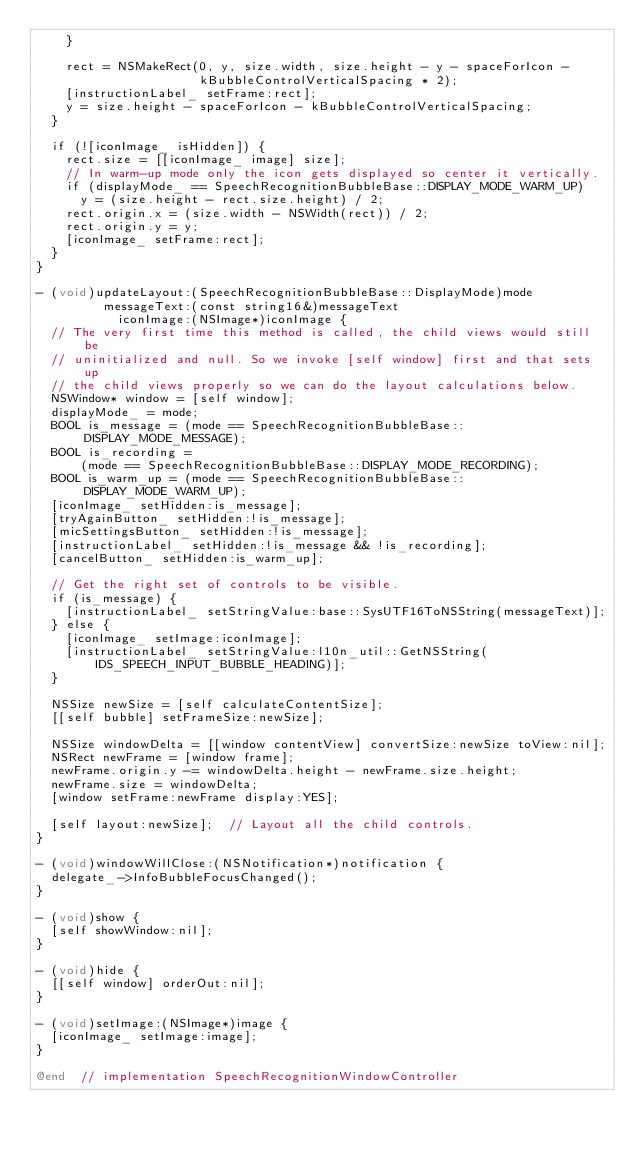<code> <loc_0><loc_0><loc_500><loc_500><_ObjectiveC_>    }

    rect = NSMakeRect(0, y, size.width, size.height - y - spaceForIcon -
                      kBubbleControlVerticalSpacing * 2);
    [instructionLabel_ setFrame:rect];
    y = size.height - spaceForIcon - kBubbleControlVerticalSpacing;
  }

  if (![iconImage_ isHidden]) {
    rect.size = [[iconImage_ image] size];
    // In warm-up mode only the icon gets displayed so center it vertically.
    if (displayMode_ == SpeechRecognitionBubbleBase::DISPLAY_MODE_WARM_UP)
      y = (size.height - rect.size.height) / 2;
    rect.origin.x = (size.width - NSWidth(rect)) / 2;
    rect.origin.y = y;
    [iconImage_ setFrame:rect];
  }
}

- (void)updateLayout:(SpeechRecognitionBubbleBase::DisplayMode)mode
         messageText:(const string16&)messageText
           iconImage:(NSImage*)iconImage {
  // The very first time this method is called, the child views would still be
  // uninitialized and null. So we invoke [self window] first and that sets up
  // the child views properly so we can do the layout calculations below.
  NSWindow* window = [self window];
  displayMode_ = mode;
  BOOL is_message = (mode == SpeechRecognitionBubbleBase::DISPLAY_MODE_MESSAGE);
  BOOL is_recording =
      (mode == SpeechRecognitionBubbleBase::DISPLAY_MODE_RECORDING);
  BOOL is_warm_up = (mode == SpeechRecognitionBubbleBase::DISPLAY_MODE_WARM_UP);
  [iconImage_ setHidden:is_message];
  [tryAgainButton_ setHidden:!is_message];
  [micSettingsButton_ setHidden:!is_message];
  [instructionLabel_ setHidden:!is_message && !is_recording];
  [cancelButton_ setHidden:is_warm_up];

  // Get the right set of controls to be visible.
  if (is_message) {
    [instructionLabel_ setStringValue:base::SysUTF16ToNSString(messageText)];
  } else {
    [iconImage_ setImage:iconImage];
    [instructionLabel_ setStringValue:l10n_util::GetNSString(
        IDS_SPEECH_INPUT_BUBBLE_HEADING)];
  }

  NSSize newSize = [self calculateContentSize];
  [[self bubble] setFrameSize:newSize];

  NSSize windowDelta = [[window contentView] convertSize:newSize toView:nil];
  NSRect newFrame = [window frame];
  newFrame.origin.y -= windowDelta.height - newFrame.size.height;
  newFrame.size = windowDelta;
  [window setFrame:newFrame display:YES];

  [self layout:newSize];  // Layout all the child controls.
}

- (void)windowWillClose:(NSNotification*)notification {
  delegate_->InfoBubbleFocusChanged();
}

- (void)show {
  [self showWindow:nil];
}

- (void)hide {
  [[self window] orderOut:nil];
}

- (void)setImage:(NSImage*)image {
  [iconImage_ setImage:image];
}

@end  // implementation SpeechRecognitionWindowController
</code> 